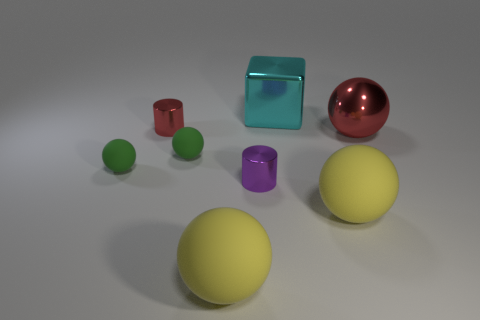Is the number of tiny red shiny cylinders greater than the number of large spheres?
Provide a succinct answer. No. What number of small things are cylinders or red metal spheres?
Provide a succinct answer. 2. What number of other things are there of the same color as the cube?
Offer a terse response. 0. How many other big cyan blocks have the same material as the big cyan cube?
Keep it short and to the point. 0. There is a cylinder on the left side of the purple metal thing; is it the same color as the big metal sphere?
Make the answer very short. Yes. What number of gray objects are small rubber balls or large shiny blocks?
Offer a terse response. 0. Does the yellow sphere to the left of the metallic block have the same material as the cyan block?
Keep it short and to the point. No. What number of things are either red metal things or big matte spheres that are left of the tiny purple metallic thing?
Make the answer very short. 3. How many small red cylinders are in front of the red object to the right of the red metallic thing on the left side of the metallic sphere?
Make the answer very short. 0. There is a red object behind the metallic sphere; does it have the same shape as the big cyan thing?
Ensure brevity in your answer.  No. 